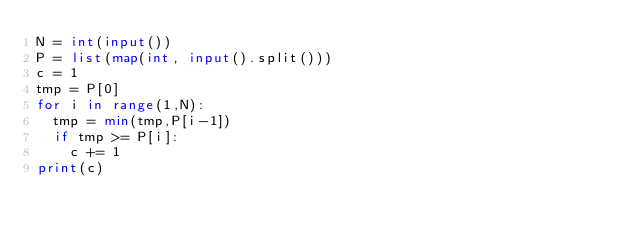Convert code to text. <code><loc_0><loc_0><loc_500><loc_500><_Python_>N = int(input())
P = list(map(int, input().split()))
c = 1
tmp = P[0]
for i in range(1,N):
  tmp = min(tmp,P[i-1])
  if tmp >= P[i]:
    c += 1
print(c)</code> 